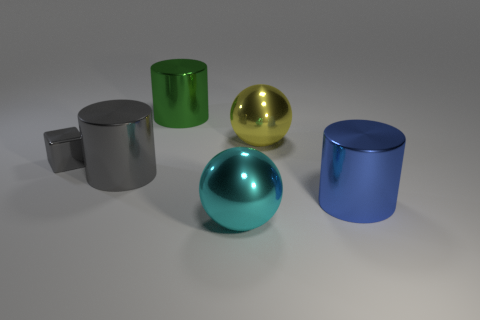Subtract all gray cylinders. How many cylinders are left? 2 Subtract 2 cylinders. How many cylinders are left? 1 Add 1 metal objects. How many objects exist? 7 Subtract all cubes. How many objects are left? 5 Add 6 gray cylinders. How many gray cylinders exist? 7 Subtract 1 cyan balls. How many objects are left? 5 Subtract all gray cylinders. Subtract all gray spheres. How many cylinders are left? 2 Subtract all blue cubes. How many gray cylinders are left? 1 Subtract all small gray cubes. Subtract all blue metal cylinders. How many objects are left? 4 Add 6 green metallic cylinders. How many green metallic cylinders are left? 7 